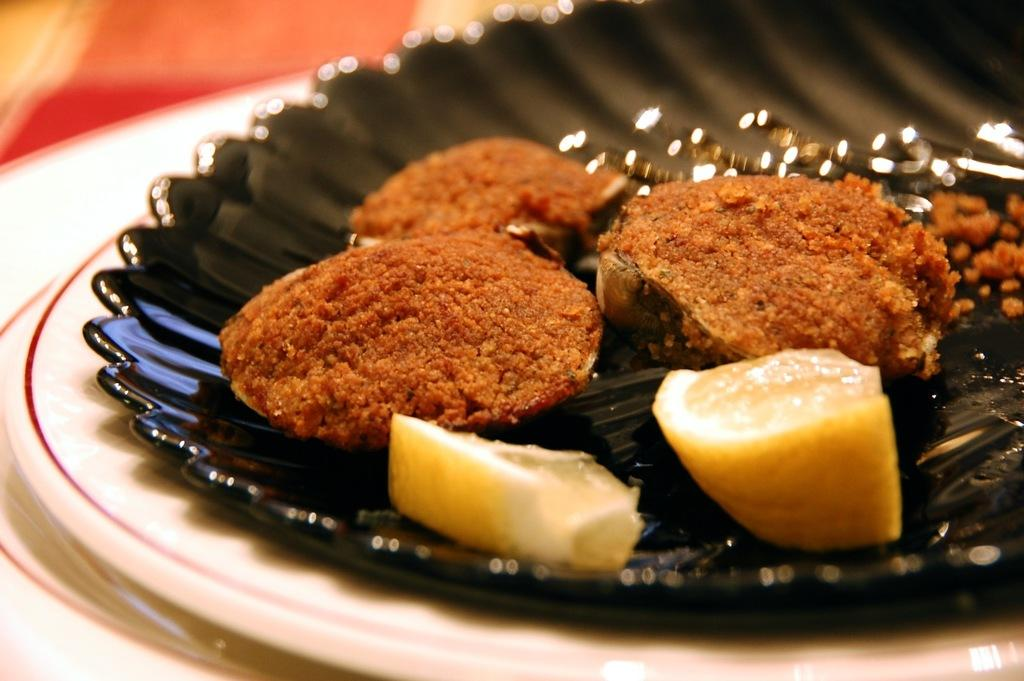What is present on the plate in the image? There is food in a plate in the image. How many dogs are sitting on the plate in the image? There are no dogs present in the image; it features a plate of food. What type of cherry is used as a garnish on the plate in the image? There is no cherry present in the image; it only features food on a plate. 